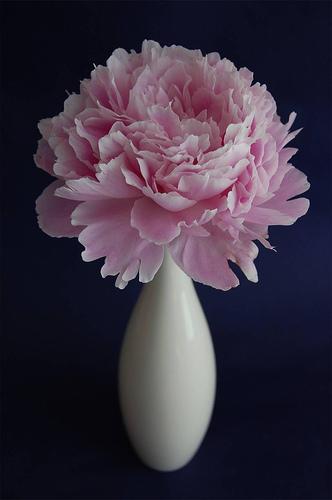Is the flower real or fake?
Answer briefly. Real. What color are the flowers?
Short answer required. Pink. Are green leaves showing?
Concise answer only. No. Is the floor made of wood?
Quick response, please. No. Are these orchids?
Short answer required. No. What color is the flower?
Be succinct. Pink. What color is the vase?
Give a very brief answer. White. What type of flower is pictured?
Write a very short answer. Carnation. Is there only one flower?
Give a very brief answer. Yes. What are the flowers in?
Concise answer only. Vase. 